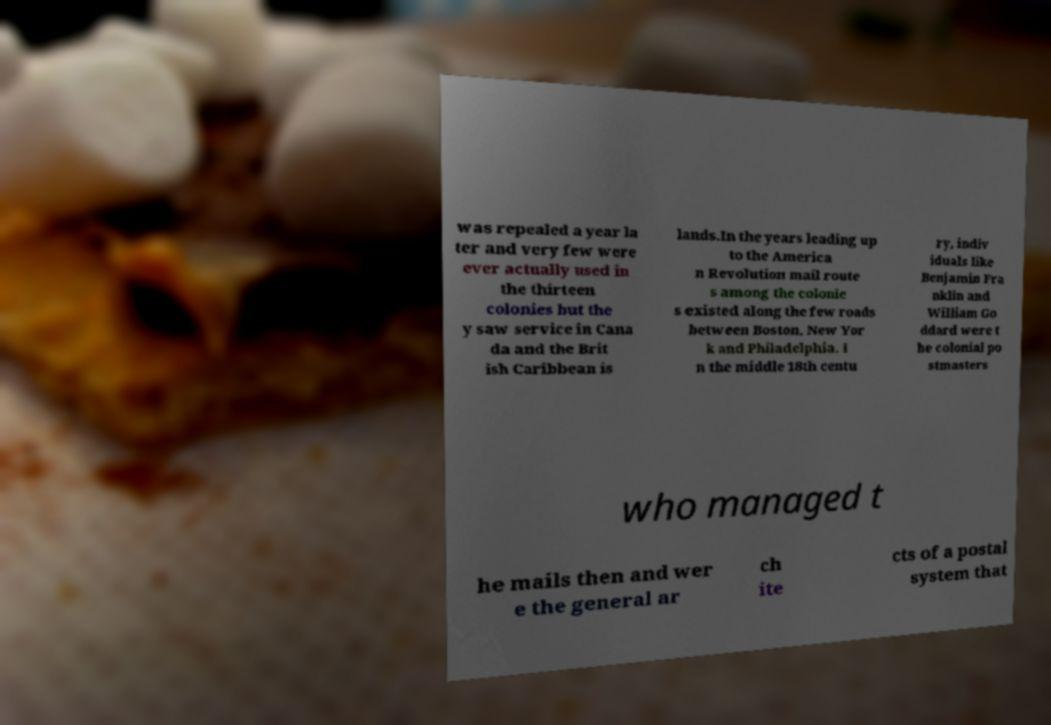I need the written content from this picture converted into text. Can you do that? was repealed a year la ter and very few were ever actually used in the thirteen colonies but the y saw service in Cana da and the Brit ish Caribbean is lands.In the years leading up to the America n Revolution mail route s among the colonie s existed along the few roads between Boston, New Yor k and Philadelphia. I n the middle 18th centu ry, indiv iduals like Benjamin Fra nklin and William Go ddard were t he colonial po stmasters who managed t he mails then and wer e the general ar ch ite cts of a postal system that 